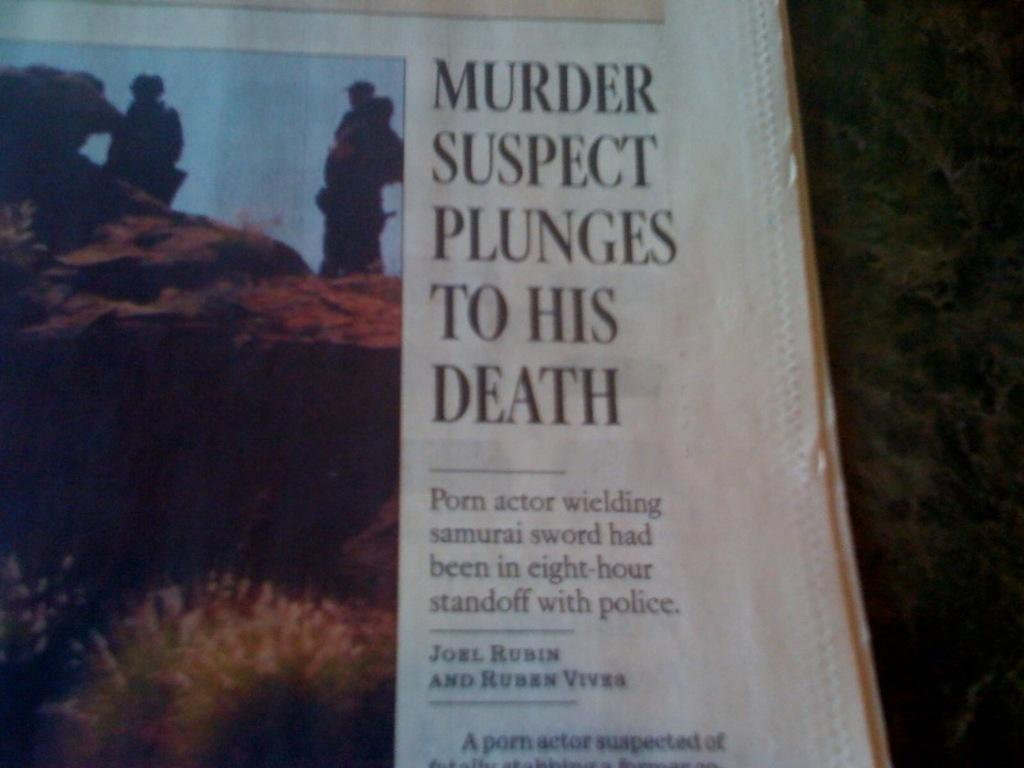<image>
Write a terse but informative summary of the picture. newpaper article about porn actor with a samurai sword 